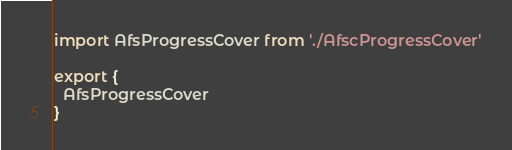<code> <loc_0><loc_0><loc_500><loc_500><_JavaScript_>import AfsProgressCover from './AfscProgressCover'

export {
  AfsProgressCover
}
</code> 